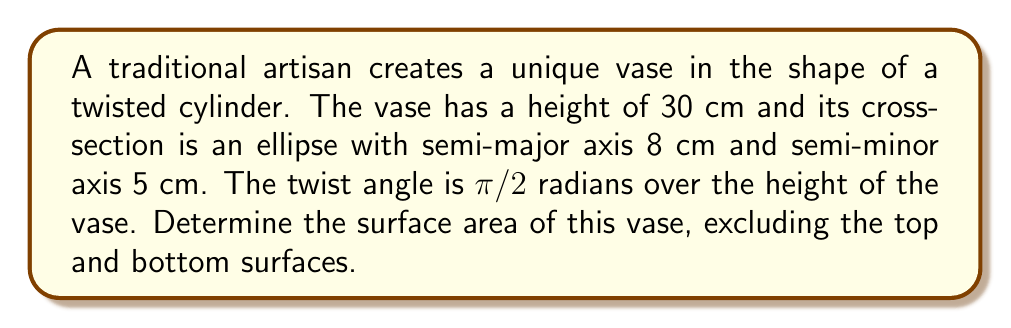Provide a solution to this math problem. To solve this problem, we'll use concepts from differential geometry:

1) First, we need to parameterize the surface. Let's use cylindrical coordinates:
   $x = a\cos\theta\cos(\frac{\pi z}{2h}) - b\sin\theta\sin(\frac{\pi z}{2h})$
   $y = a\cos\theta\sin(\frac{\pi z}{2h}) + b\sin\theta\cos(\frac{\pi z}{2h})$
   $z = z$
   
   Where $a=8$ cm, $b=5$ cm, $h=30$ cm, $0 \leq \theta \leq 2\pi$, and $0 \leq z \leq h$.

2) Calculate the partial derivatives:
   $\frac{\partial x}{\partial \theta} = -a\sin\theta\cos(\frac{\pi z}{2h}) - b\cos\theta\sin(\frac{\pi z}{2h})$
   $\frac{\partial y}{\partial \theta} = -a\sin\theta\sin(\frac{\pi z}{2h}) + b\cos\theta\cos(\frac{\pi z}{2h})$
   $\frac{\partial z}{\partial \theta} = 0$

   $\frac{\partial x}{\partial z} = -\frac{\pi}{2h}(a\cos\theta\sin(\frac{\pi z}{2h}) + b\sin\theta\cos(\frac{\pi z}{2h}))$
   $\frac{\partial y}{\partial z} = \frac{\pi}{2h}(a\cos\theta\cos(\frac{\pi z}{2h}) - b\sin\theta\sin(\frac{\pi z}{2h}))$
   $\frac{\partial z}{\partial z} = 1$

3) Calculate the cross product of these partial derivatives:
   $\left|\frac{\partial r}{\partial \theta} \times \frac{\partial r}{\partial z}\right| = \sqrt{(a\cos\theta)^2 + (b\sin\theta)^2 + (\frac{\pi}{2h})^2(a^2\cos^2\theta + b^2\sin^2\theta)}$

4) The surface area is given by the double integral:
   $$A = \int_0^h \int_0^{2\pi} \left|\frac{\partial r}{\partial \theta} \times \frac{\partial r}{\partial z}\right| d\theta dz$$

5) Simplify the integrand:
   $\left|\frac{\partial r}{\partial \theta} \times \frac{\partial r}{\partial z}\right| = \sqrt{a^2\cos^2\theta + b^2\sin^2\theta} \sqrt{1 + (\frac{\pi}{2h})^2}$

6) The integral becomes:
   $$A = h\sqrt{1 + (\frac{\pi}{2h})^2} \int_0^{2\pi} \sqrt{a^2\cos^2\theta + b^2\sin^2\theta} d\theta$$

7) The remaining integral is the circumference of an ellipse, which can be approximated using Ramanujan's formula:
   $$C \approx \pi(a+b)\left(1 + \frac{3h}{10 + \sqrt{4-3h}}\right)$$
   where $h = \frac{(a-b)^2}{(a+b)^2}$

8) Substituting the values and calculating:
   $h = \frac{(8-5)^2}{(8+5)^2} = \frac{9}{169}$
   $C \approx \pi(8+5)\left(1 + \frac{3(9/169)}{10 + \sqrt{4-3(9/169)}}\right) \approx 41.93$ cm

9) Finally, the surface area is:
   $$A = 30\sqrt{1 + (\frac{\pi}{2(30)})^2} \cdot 41.93 \approx 1266.43 \text{ cm}^2$$
Answer: $1266.43 \text{ cm}^2$ 